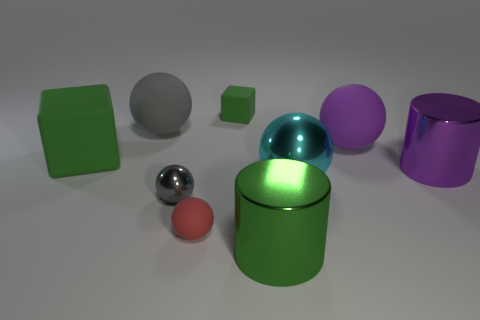Are the cylinder that is behind the green metallic object and the large green thing that is behind the big green shiny cylinder made of the same material?
Provide a short and direct response. No. What color is the other metal object that is the same shape as the small gray thing?
Give a very brief answer. Cyan. There is a block to the left of the small ball to the right of the gray metal thing; what is it made of?
Ensure brevity in your answer.  Rubber. There is a small object behind the large purple metallic object; is its shape the same as the large green object to the left of the large green cylinder?
Make the answer very short. Yes. How big is the matte thing that is both on the right side of the red matte thing and in front of the small green object?
Offer a very short reply. Large. What number of other objects are there of the same color as the large matte cube?
Ensure brevity in your answer.  2. Does the cube in front of the small cube have the same material as the big purple cylinder?
Ensure brevity in your answer.  No. Are there fewer purple rubber balls on the right side of the red matte thing than small objects that are on the left side of the large purple cylinder?
Your answer should be compact. Yes. What material is the ball that is the same color as the small metal thing?
Your response must be concise. Rubber. There is a matte cube that is in front of the green rubber thing right of the big green cube; what number of small shiny spheres are to the left of it?
Offer a very short reply. 0. 